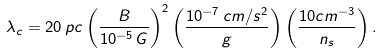<formula> <loc_0><loc_0><loc_500><loc_500>\lambda _ { c } = 2 0 \, p c \left ( \frac { B } { 1 0 ^ { - 5 } \, G } \right ) ^ { 2 } \left ( \frac { 1 0 ^ { - 7 } \, c m / s ^ { 2 } } { g } \right ) \left ( \frac { 1 0 c m ^ { - 3 } } { n _ { s } } \right ) .</formula> 